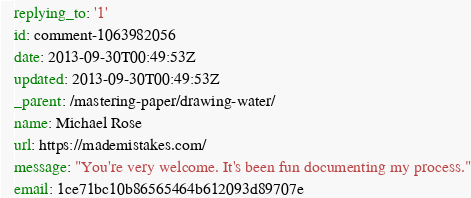Convert code to text. <code><loc_0><loc_0><loc_500><loc_500><_YAML_>replying_to: '1'
id: comment-1063982056
date: 2013-09-30T00:49:53Z
updated: 2013-09-30T00:49:53Z
_parent: /mastering-paper/drawing-water/
name: Michael Rose
url: https://mademistakes.com/
message: "You're very welcome. It's been fun documenting my process."
email: 1ce71bc10b86565464b612093d89707e
</code> 